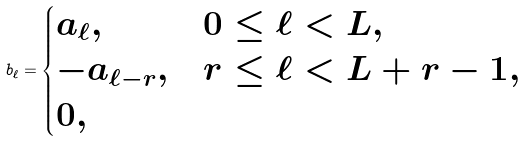Convert formula to latex. <formula><loc_0><loc_0><loc_500><loc_500>b _ { \ell } = \begin{cases} a _ { \ell } , & 0 \leq \ell < L , \\ - a _ { \ell - r } , & r \leq \ell < L + r - 1 , \\ 0 , & \end{cases}</formula> 